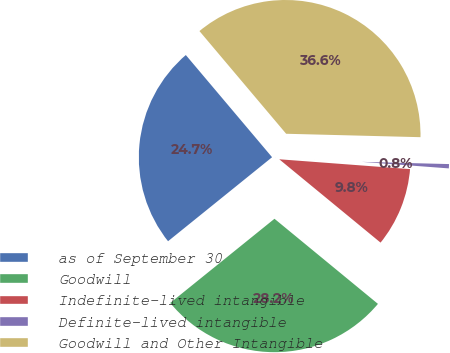<chart> <loc_0><loc_0><loc_500><loc_500><pie_chart><fcel>as of September 30<fcel>Goodwill<fcel>Indefinite-lived intangible<fcel>Definite-lived intangible<fcel>Goodwill and Other Intangible<nl><fcel>24.65%<fcel>28.23%<fcel>9.76%<fcel>0.79%<fcel>36.56%<nl></chart> 